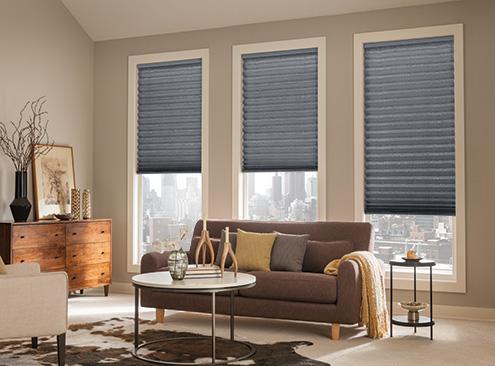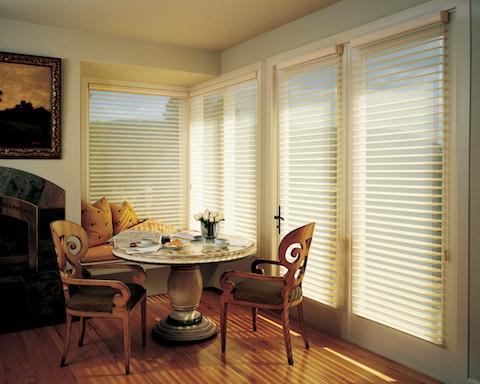The first image is the image on the left, the second image is the image on the right. For the images displayed, is the sentence "A window blind is partially pulled up in both images." factually correct? Answer yes or no. No. The first image is the image on the left, the second image is the image on the right. Assess this claim about the two images: "There is a total of seven shades.". Correct or not? Answer yes or no. Yes. 